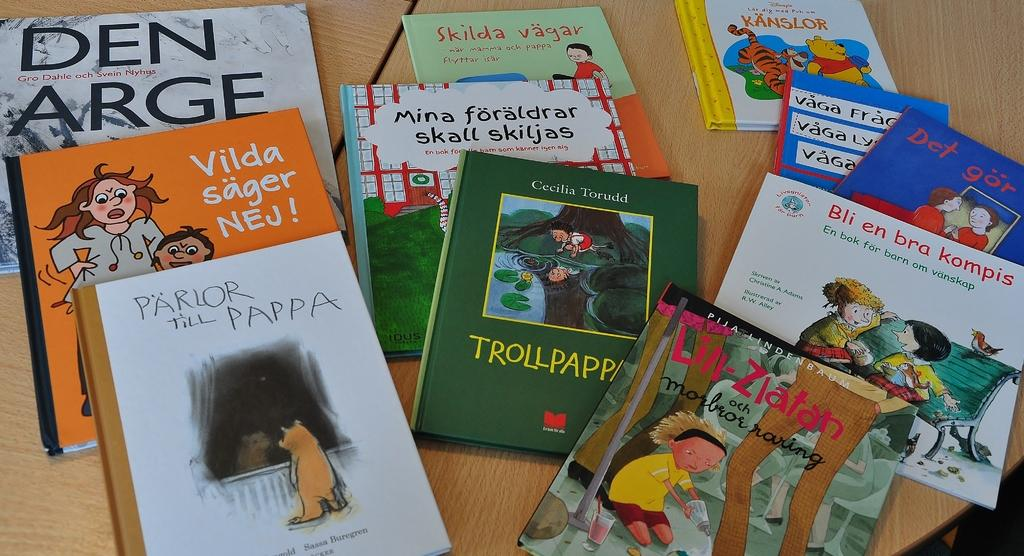<image>
Create a compact narrative representing the image presented. A bunch of kids books on a table, one of which is titled Parlor Till Pappa. 